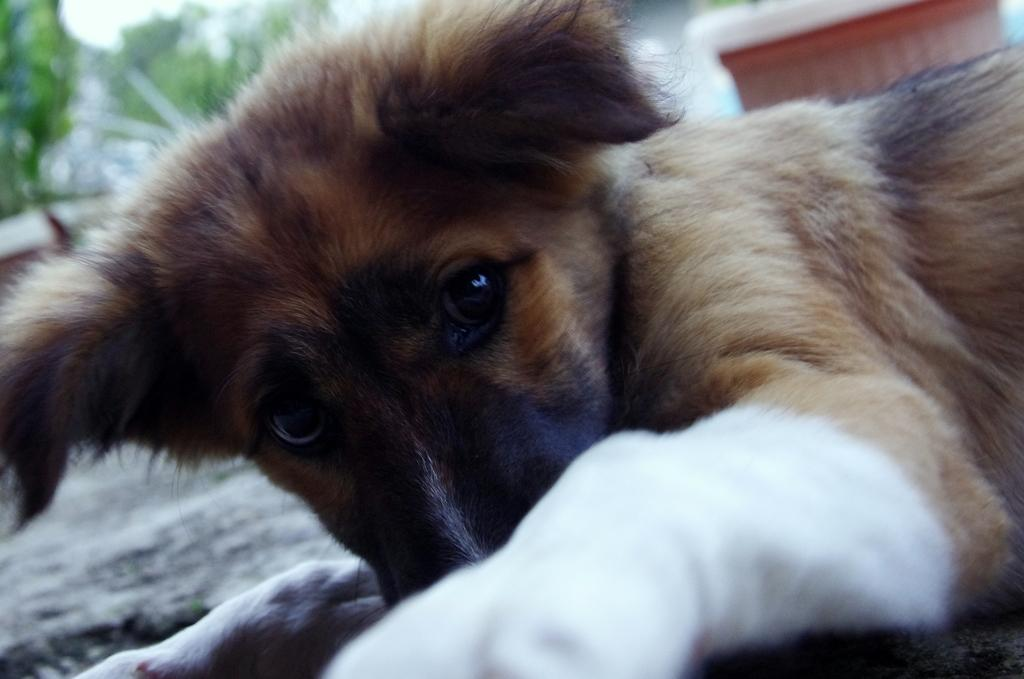What type of animal is in the image? The animal in the image has brown, black, and white colors, but we cannot definitively identify the species from the provided facts. What can be seen in the background of the image? There are many trees and the sky visible in the background of the image. How would you describe the background of the image? The background is blurry. What type of discovery is being made by the animal in the image? There is no indication in the image that the animal is making any discovery. 